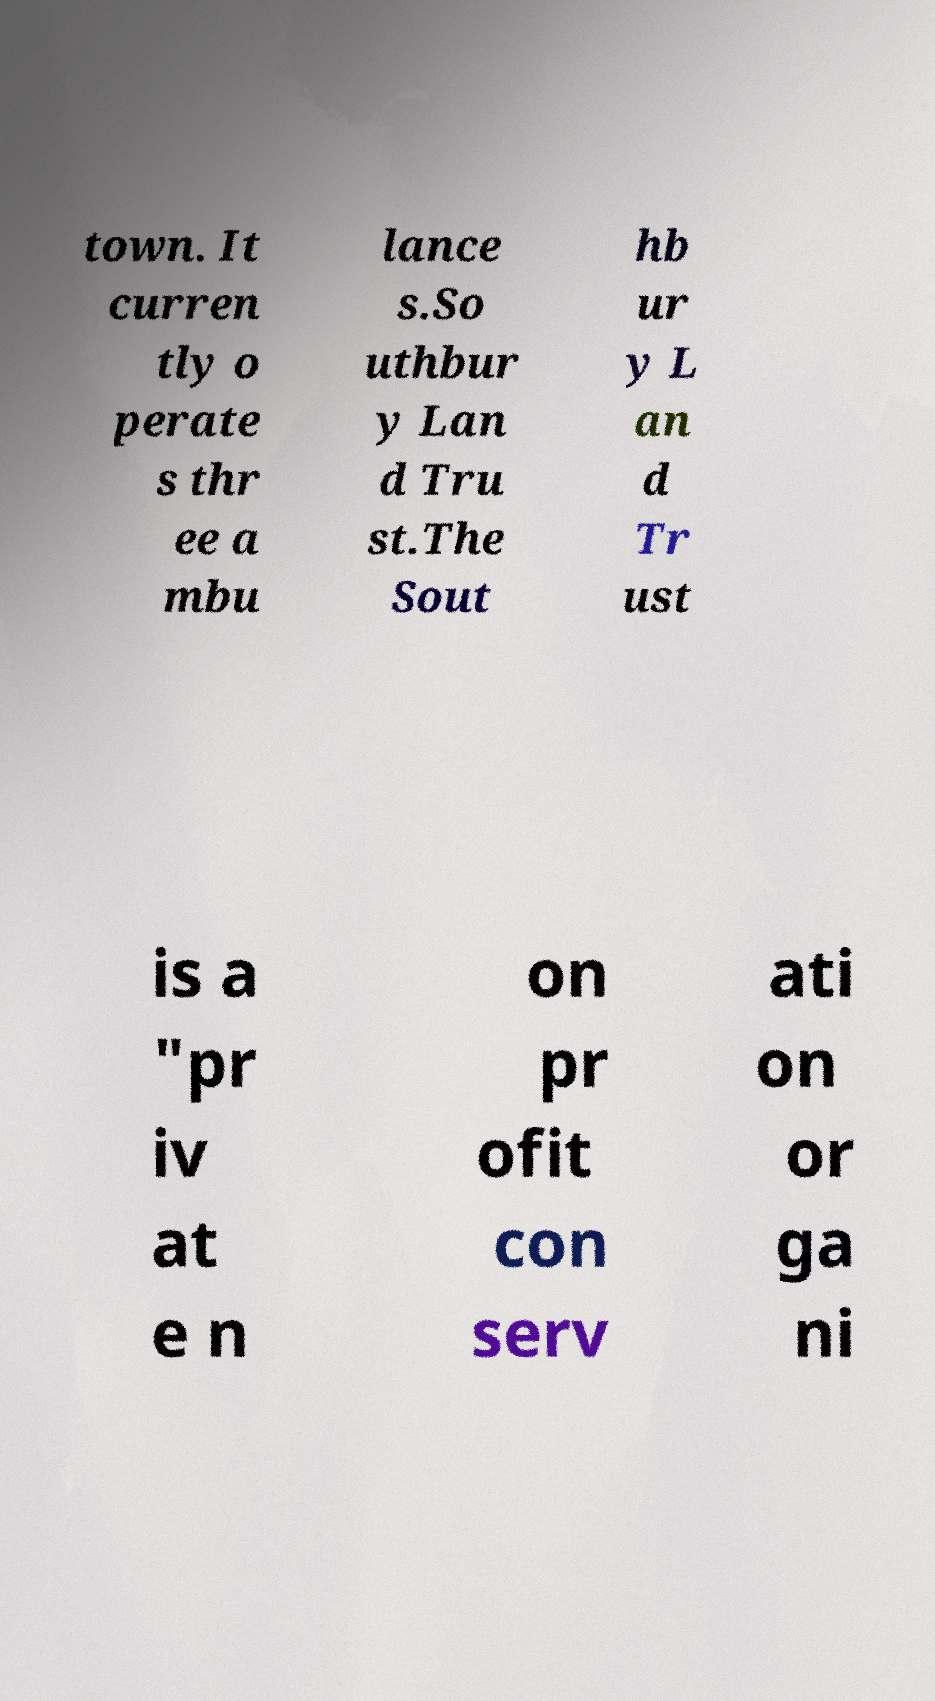Can you accurately transcribe the text from the provided image for me? town. It curren tly o perate s thr ee a mbu lance s.So uthbur y Lan d Tru st.The Sout hb ur y L an d Tr ust is a "pr iv at e n on pr ofit con serv ati on or ga ni 